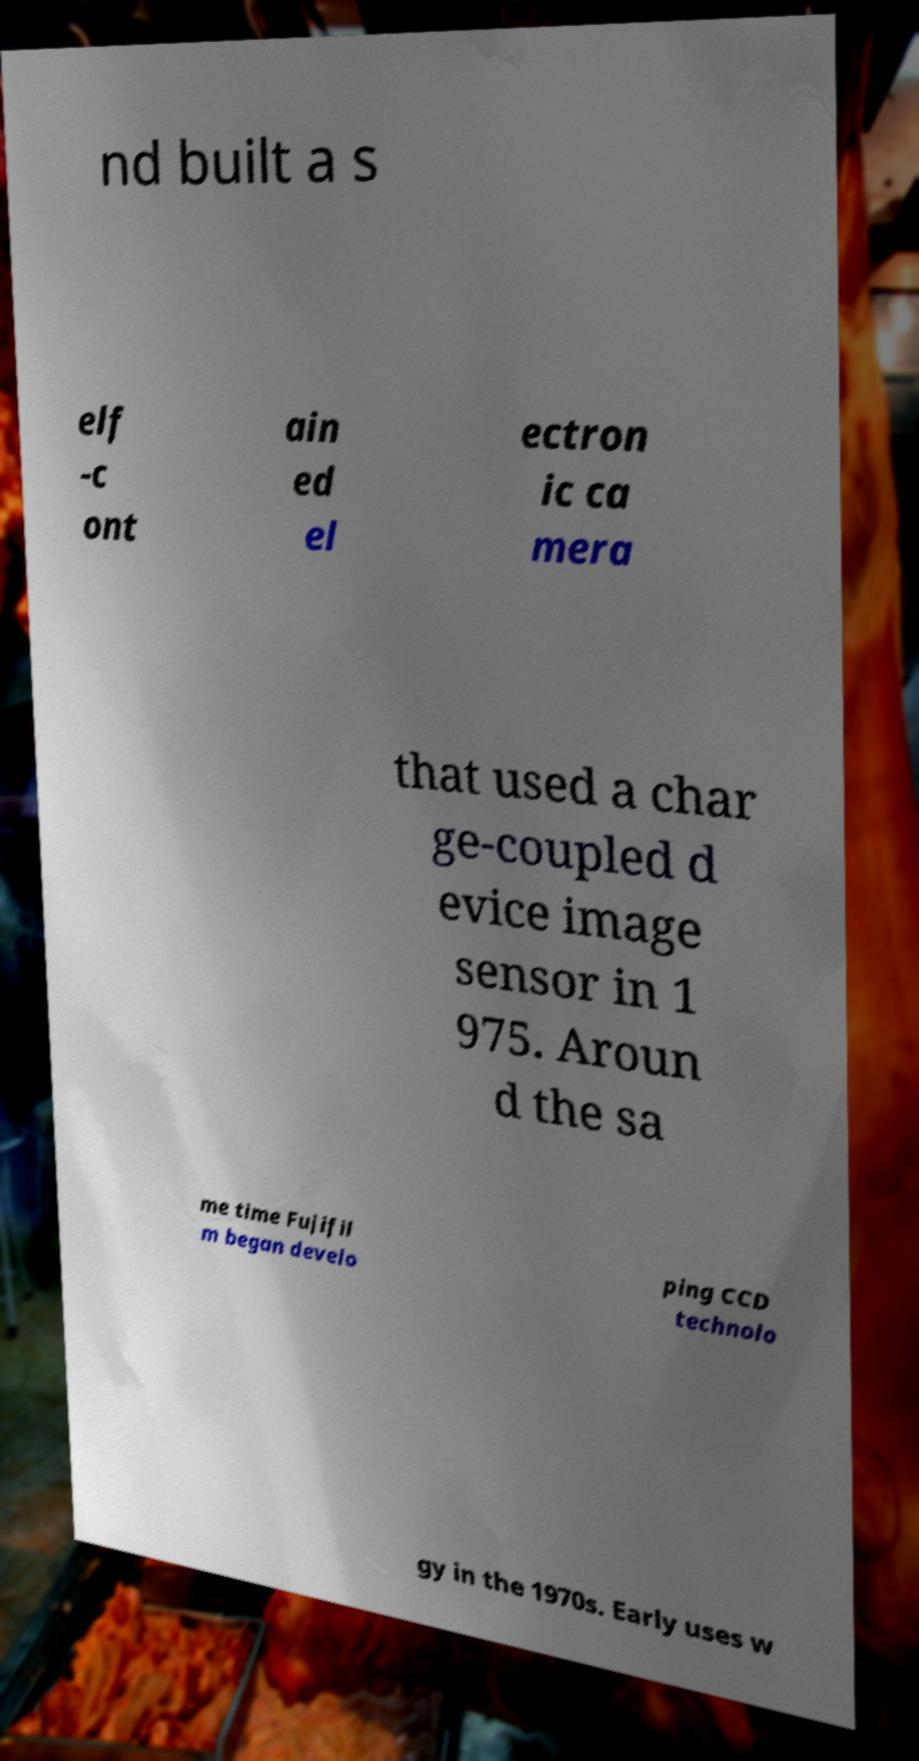Can you read and provide the text displayed in the image?This photo seems to have some interesting text. Can you extract and type it out for me? nd built a s elf -c ont ain ed el ectron ic ca mera that used a char ge-coupled d evice image sensor in 1 975. Aroun d the sa me time Fujifil m began develo ping CCD technolo gy in the 1970s. Early uses w 